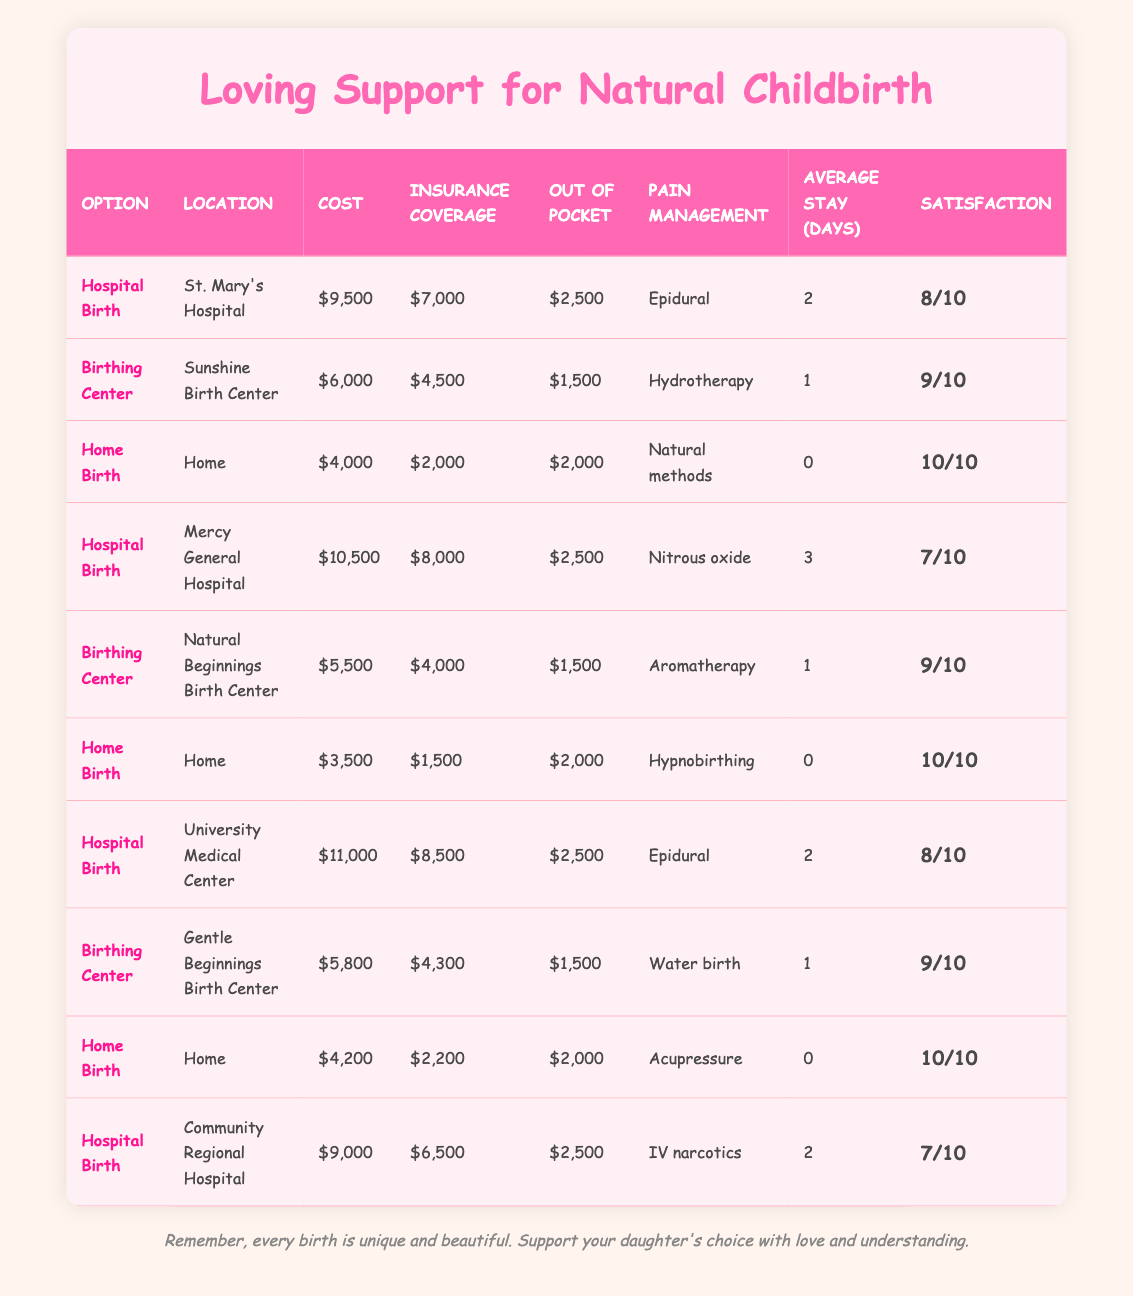What is the lowest out-of-pocket cost among the childbirth options? The out-of-pocket costs listed in the table are $2,500 (Hospital Birth), $1,500 (Birthing Center), $2,000 (Home Birth), and $2000 (Home Birth). The lowest out-of-pocket cost is the $1,500, which corresponds to the Birthing Center at Sunshine Birth Center and Natural Beginnings Birth Center.
Answer: 1500 What is the average cost of a Home Birth? The total costs for Home Birth options are $4,000, $3,500, and $4,200, which sum to $11,700. There are three entries, so the average cost is $11,700 divided by 3, resulting in $3,900.
Answer: 3900 Which childbirth option has the highest satisfaction rating? The satisfaction ratings listed are 8, 9, 10, 7, 9, 10, 8, 9, 10, and 7. The highest rating is 10, which corresponds to the Home Birth options.
Answer: Home Birth Is the total insurance coverage for all the Birthing Center options greater than that for Hospital Birth options? The total insurance coverage for the Birthing Center options is $4,500 + $4,000 + $4,300 = $12,800. The total insurance coverage for Hospital Birth options is $7,000 + $8,000 + $8,500 + $6,500 = $30,000. Since $12,800 is less than $30,000, the statement is false.
Answer: No What is the average stay in days for all childbirth options? The average stay is calculated by adding up all the stay days: 2 + 1 + 0 + 3 + 1 + 0 + 2 + 1 + 0 + 2 = 12 days. There are 10 options total, so the average is 12 days divided by 10, resulting in 1.2 days.
Answer: 1.2 Which option offers a lower cost than $5,500? The childbirth options with costs less than $5,500 are Home Birth ($4,000), Home Birth ($3,500), and the Birthing Center options ($6,000 is excluded). Therefore, the options fitting this criteria are the two Home Births and the Birthing Center at Natural Beginnings Hospital ($5,500) is not included.
Answer: Home Birth, Home Birth Is the average insurance coverage for Hospital Births greater than $8,000? The total insurance coverages for Hospital Births are $7,000 + $8,000 + $8,500 + $6,500 = $30,000, giving an average of $30,000 divided by 4, which is $7,500. Since $7,500 is less than $8,000, the statement is false.
Answer: No What is the difference between the maximum and minimum costs of childbirth options? The maximum cost is $11,000 (University Medical Center), and the minimum cost is $3,500 (Home Birth). The difference is $11,000 - $3,500 = $7,500.
Answer: 7500 What is the total out-of-pocket cost for all childbirth options combined? Summing the out-of-pocket amounts gives $2,500 + $1,500 + $2,000 + $2,500 + $1,500 + $2,000 + $2,500 + $1,500 + $2,000 + $2,500 = $23,000.
Answer: 23000 